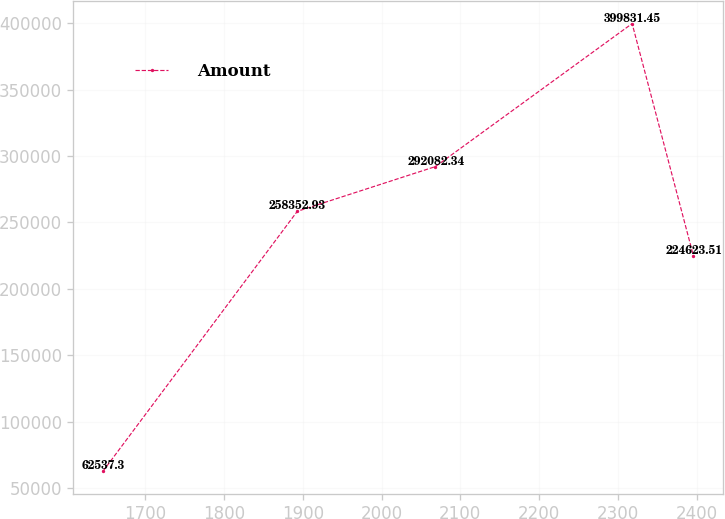Convert chart. <chart><loc_0><loc_0><loc_500><loc_500><line_chart><ecel><fcel>Amount<nl><fcel>1646.38<fcel>62537.3<nl><fcel>1893.02<fcel>258353<nl><fcel>2068.38<fcel>292082<nl><fcel>2318.1<fcel>399831<nl><fcel>2396<fcel>224624<nl></chart> 